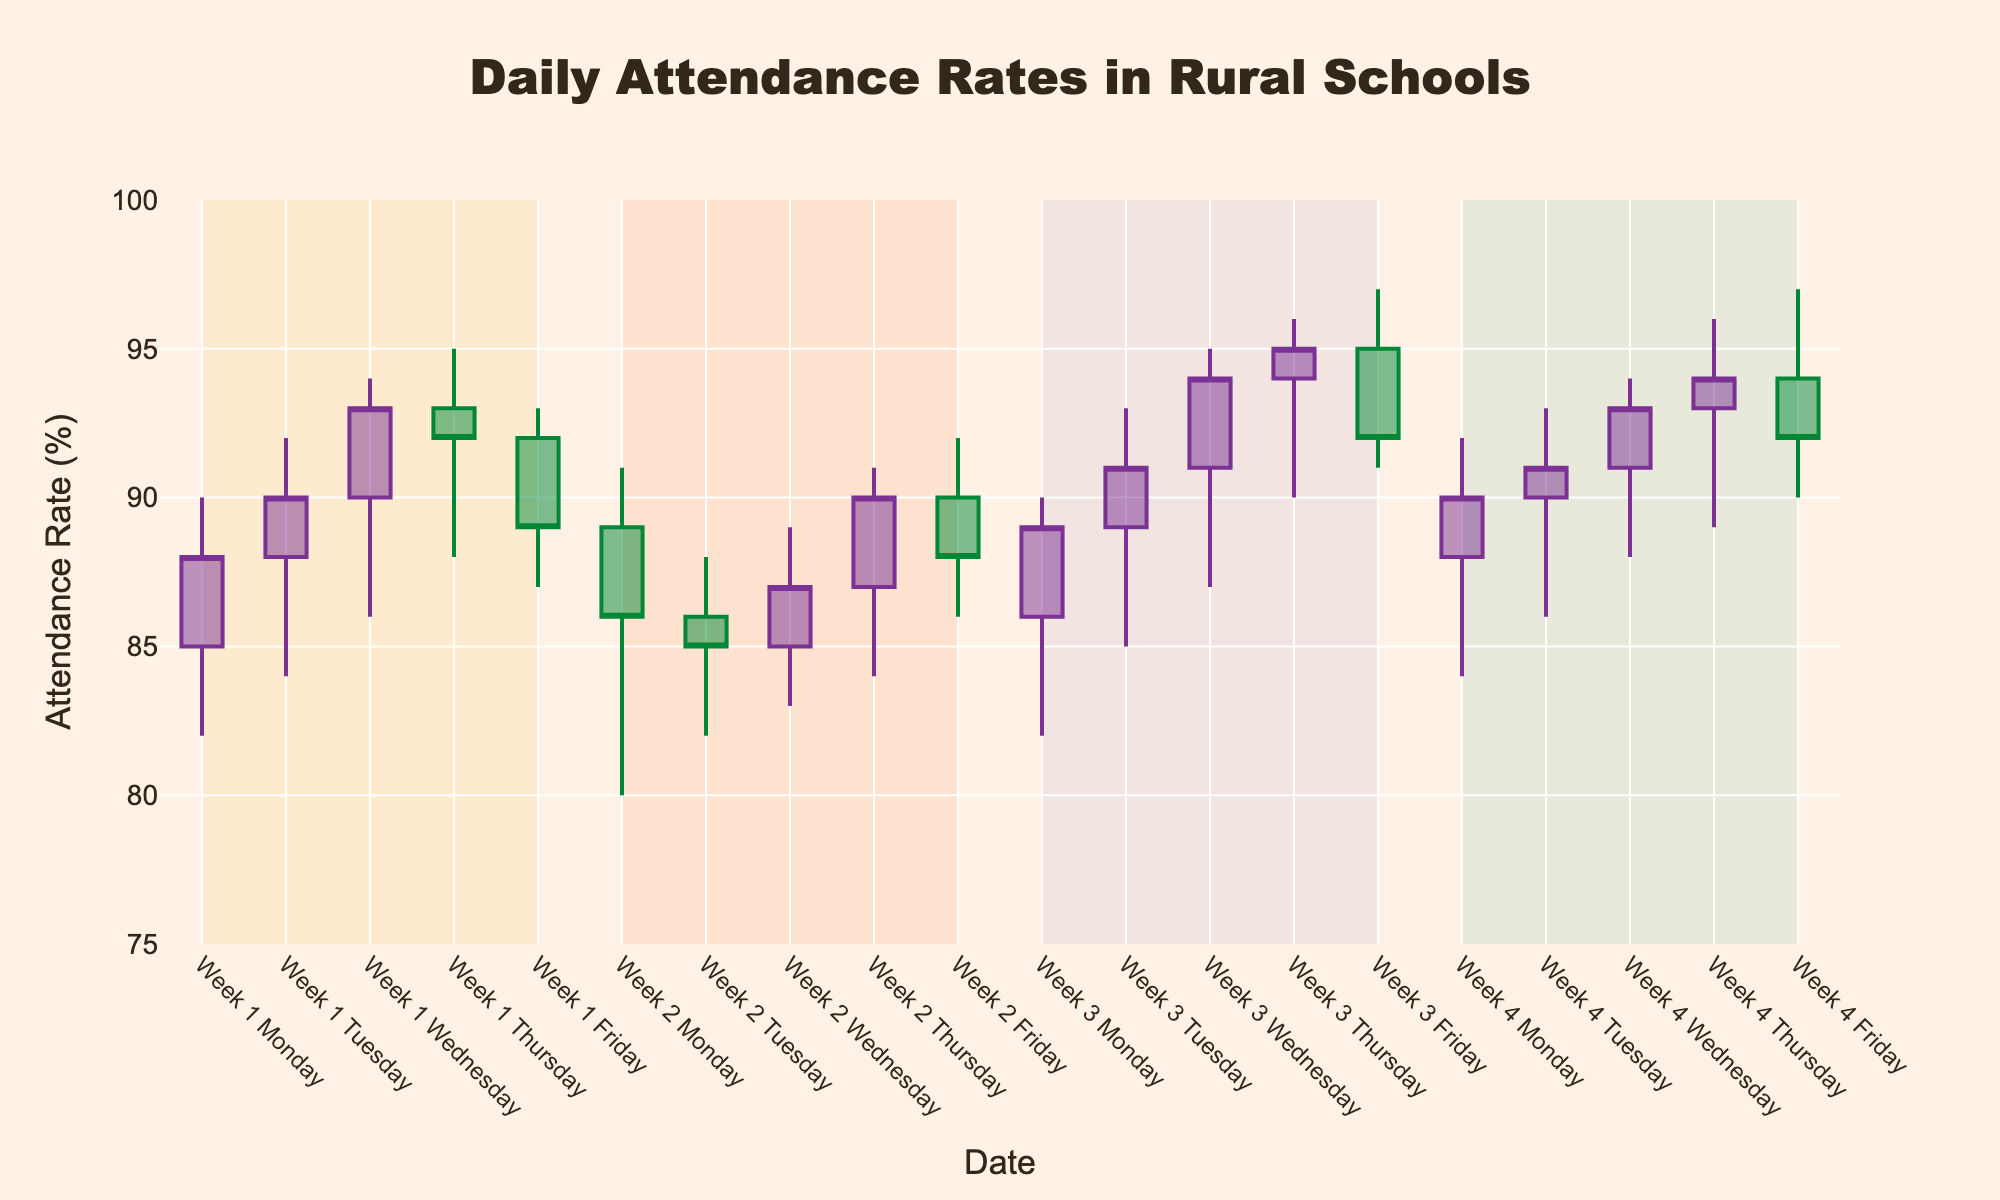what is the title of the plot? The title is usually located at the top of a figure and tells you what the plot is about. In this case, it is "Daily Attendance Rates in Rural Schools"
Answer: Daily Attendance Rates in Rural Schools What are the highest and lowest attendance rates recorded in the plot? The highest and lowest values can be seen by looking at the 'high' and 'low' values of the candlesticks. The highest attendance rate is 97%, and the lowest is 80%
Answer: highest: 97%, lowest: 80% Which day had the lowest closing attendance in Week 2? Locate the days in Week 2 and compare their closing attendance rates. The lowest closing attendance rate is 85% on Tuesday.
Answer: Tuesday How does the average closing attendance in Week 1 compare to Week 2? Calculate the average closing attendance for both weeks separately. For Week 1: (88 + 90 + 93 + 92 + 89)/5 = 90.4%; for Week 2: (86 + 85 + 87 + 90 + 88)/5 = 87.2%. Week 1 has a higher average closing attendance.
Answer: Week 1 higher On which day does the plot show the highest daily increase in attendance rate? The highest daily increase is observed by looking at the difference between the opening and closing rates. Wednesday in Week 4 has the highest increase: 93 - 91 = 2%.
Answer: Wednesday (Week 4) Which week had the most consistently high attendance rates? Evaluate the candlestick patterns across all weeks. Week 4 shows the consistently highest attendance rates, as shown by the regular high and closing values.
Answer: Week 4 Which day in Week 3 had the largest range between high and low attendance? Calculate the range by subtracting the low value from the high value for each day. Thursday in Week 3 has the highest range: 96 - 90 = 6%.
Answer: Thursday How does the attendance on Fridays compare across all weeks? Compare the closing attendance rates on Fridays for each week. Week 1: 89%, Week 2: 88%, Week 3: 92%, Week 4: 92%. Week 3 and Week 4 have equal highest attendance rates of 92%.
Answer: Week 3 & Week 4 equal In which week did the attendance rate show the largest variation? Look at the variance in high and low values for each week. Week 2 shows the largest variation with values ranging from 80% to 92%.
Answer: Week 2 